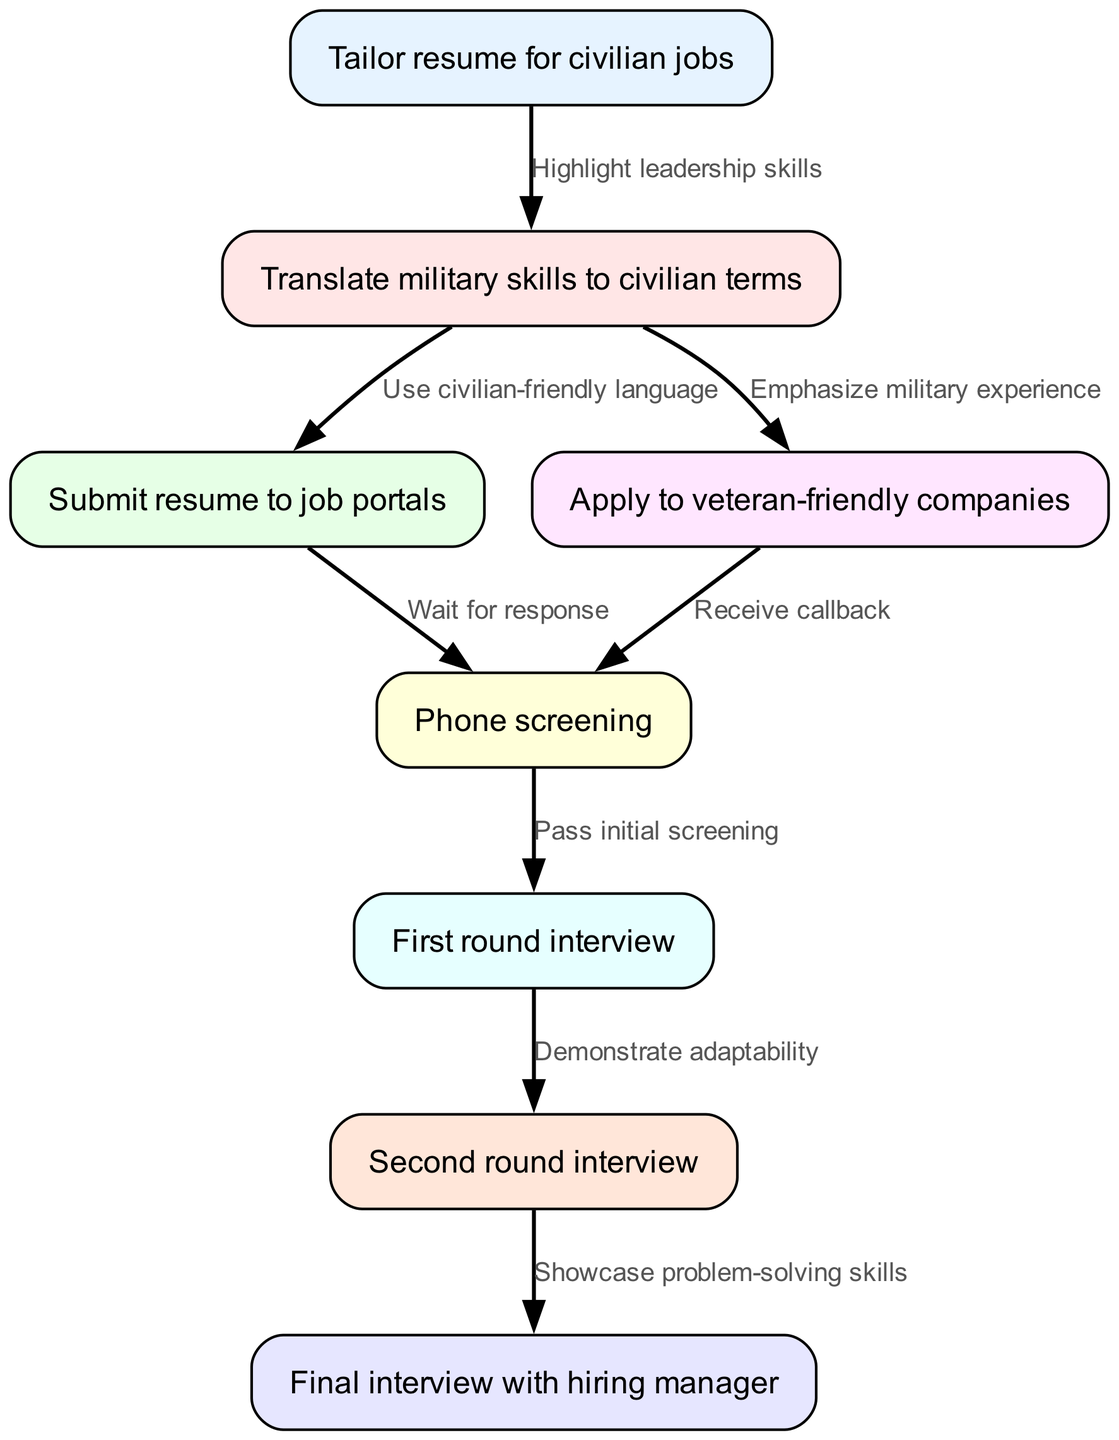What is the first step in the job application process? The first step in the job application process is represented by node 1, which states "Tailor resume for civilian jobs." This is the starting point of the flowchart, indicating that job seekers should customize their resumes.
Answer: Tailor resume for civilian jobs How many total nodes are present in the diagram? By counting the nodes listed in the data, we see there are 8 distinct nodes that represent different stages in the job application process.
Answer: 8 What is the connection between the nodes "Tailor resume for civilian jobs" and "Translate military skills to civilian terms"? The edge between node 1 and node 2 is labeled "Highlight leadership skills," which indicates that emphasizing leadership from military experience is the link between tailoring the resume and translating skills.
Answer: Highlight leadership skills What step follows after submitting the resume to job portals? After submitting the resume to job portals at node 3, the next step represented by edge 3 to node 5 is "Wait for response," which indicates that the job applicant must await feedback.
Answer: Wait for response Which two steps lead to a phone screening? There are two edges leading to the phone screening (node 5): one from node 3 ("Wait for response") and one from node 4 ("Receive callback"), indicating that both submitting the resume and applying to veteran-friendly companies can lead to a phone screening.
Answer: Wait for response and Receive callback Which interview stage requires demonstrating adaptability? The stage requiring demonstrating adaptability is represented by edge 6 leading from node 6 to node 7, which is specifically labeled "Demonstrate adaptability." This indicates that adaptability is crucial in the first round interview.
Answer: Demonstrate adaptability What is the last stage in the job application process? The last stage in the job application process is represented by node 8, which is "Final interview with hiring manager." This is the concluding step where candidates meet with the final decision-maker.
Answer: Final interview with hiring manager What is emphasized when translating military skills to civilian terms? When translating military skills to civilian terms, one should "Use civilian-friendly language" as indicated by the edge between node 2 and node 3, ensuring that military jargon is transformed into accessible language for the civilian job market.
Answer: Use civilian-friendly language Which node follows the second round interview? The second round interview is represented by node 7, and it leads to node 8 labeled "Final interview with hiring manager," which is the next step in the job application process.
Answer: Final interview with hiring manager 